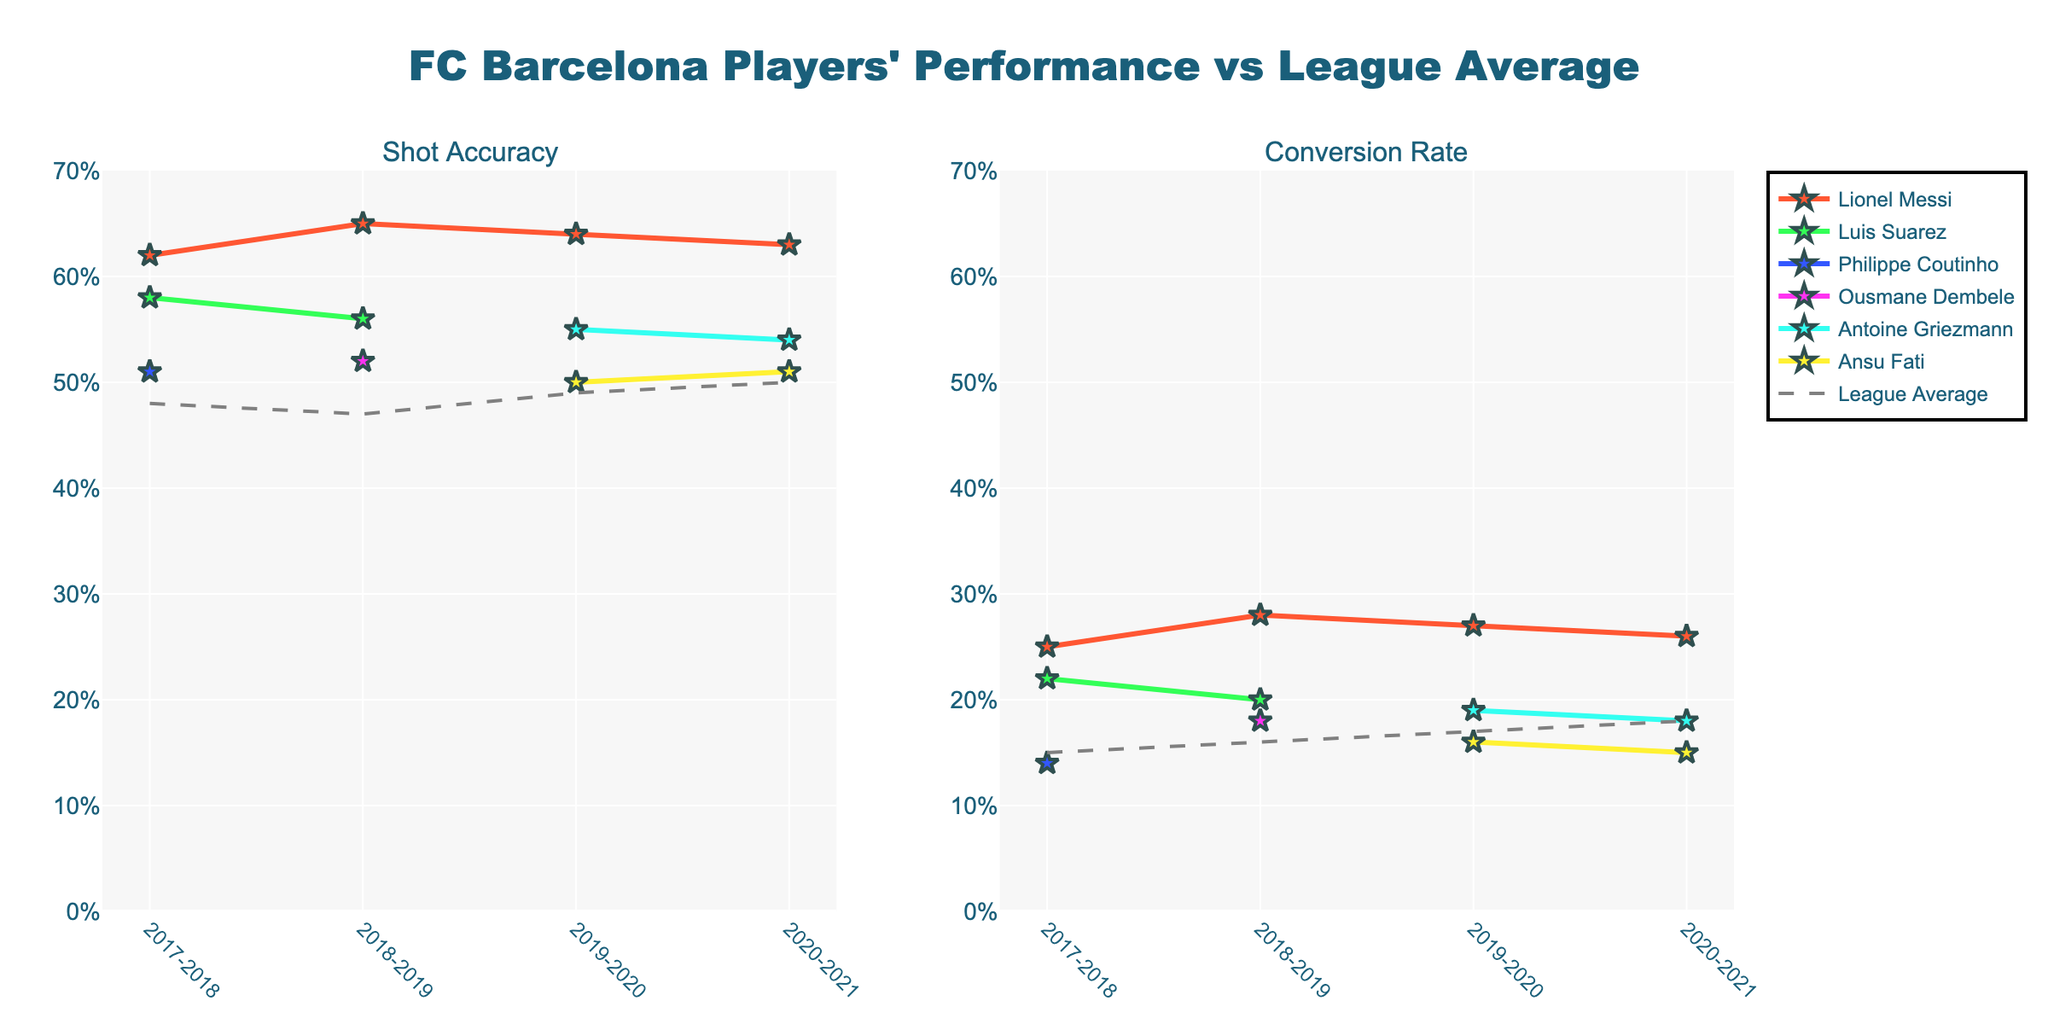What's the overall trend in Lionel Messi's Shot Accuracy from 2017-2021? From the figure, we observe Lionel Messi's Shot Accuracy over the given seasons: 0.62 in 2017-2018, 0.65 in 2018-2019, 0.64 in 2019-2020, and 0.63 in 2020-2021. Despite a slight decrease after 2018-2019, Messi's Shot Accuracy remains consistently high across the seasons.
Answer: Consistently high How does Ansu Fati's Shot Accuracy in the 2019-2020 season compare to the league average of that season? From the figure, Ansu Fati's Shot Accuracy in the 2019-2020 season is 0.50. The league average for that season is 0.49. Comparative analysis shows Ansu Fati's Shot Accuracy is marginally higher than the league average in 2019-2020.
Answer: Higher Which player had the highest Conversion Rate in the 2018-2019 season? Referring to the Conversion Rates in the 2018-2019 season, Lionel Messi (0.28), Luis Suarez (0.20), and Ousmane Dembele (0.18). Comparing these, Lionel Messi has the highest Conversion Rate in that season.
Answer: Lionel Messi What is the relationship between Lionel Messi's Shot Accuracy and Conversion Rate in the 2020-2021 season? In the 2020-2021 season, Lionel Messi's Shot Accuracy is 0.63 and his Conversion Rate is 0.26. While both metrics are high, the Shot Accuracy is significantly higher than the Conversion Rate, indicating that while he frequently gets shots on target, not all of them result in goals.
Answer: Shot Accuracy is higher than Conversion Rate Which season shows the closest Shot Accuracy for FC Barcelona players to the league average? Observing the figure, in the 2020-2021 season, Ansu Fati's Shot Accuracy is 0.51, which is very close to the league average of 0.50 for the season. No other season shows FC Barcelona players' Shot Accuracy as close to the league average.
Answer: 2020-2021 In which season did Lionel Messi outperform the league average the most in terms of Conversion Rate? Lionel Messi's Conversion Rates across the seasons are compared to the league averages: 0.10 above in 2017-2018, 0.12 above in 2018-2019, 0.10 above in 2019-2020, and 0.08 above in 2020-2021. Messi outperformed the league average the most in the 2018-2019 season with a difference of 0.12.
Answer: 2018-2019 How does Antoine Griezmann's Shot Accuracy change from the 2019-2020 season to the 2020-2021 season? Observing the figure, Antoine Griezmann's Shot Accuracy is 0.55 in the 2019-2020 season, and in the 2020-2021 season, it drops to 0.54. This shows a slight decrease in his Shot Accuracy between these seasons.
Answer: Slight decrease Which player had a higher Conversion Rate in the 2017-2018 season, Luis Suarez or Philippe Coutinho? Comparing Conversion Rates in the 2017-2018 season: Luis Suarez has 0.22 and Philippe Coutinho has 0.14. Therefore, Luis Suarez had the higher Conversion Rate.
Answer: Luis Suarez How does the trend of the league average Conversion Rate change from 2017-2021? Observing the values for league average Conversion Rate in the figure: 0.15 in 2017-2018, 0.16 in 2018-2019, 0.17 in 2019-2020, and 0.18 in 2020-2021. The trend shows a gradual increase in the league average Conversion Rate over the years.
Answer: Gradual increase 